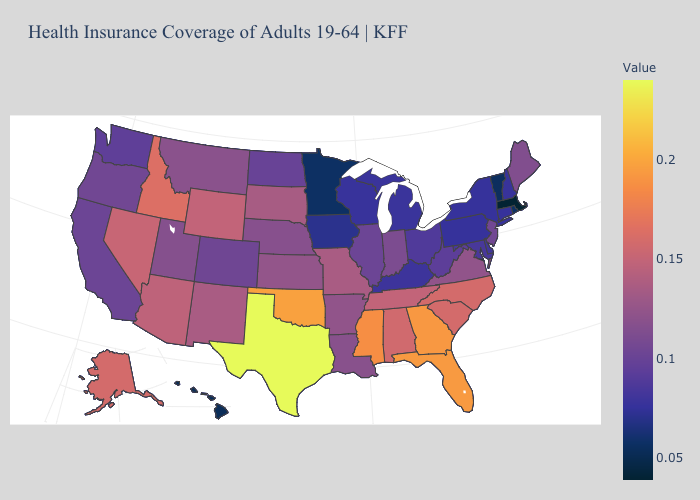Which states have the highest value in the USA?
Be succinct. Texas. Does Tennessee have the highest value in the USA?
Keep it brief. No. Among the states that border Colorado , does Utah have the lowest value?
Concise answer only. Yes. 